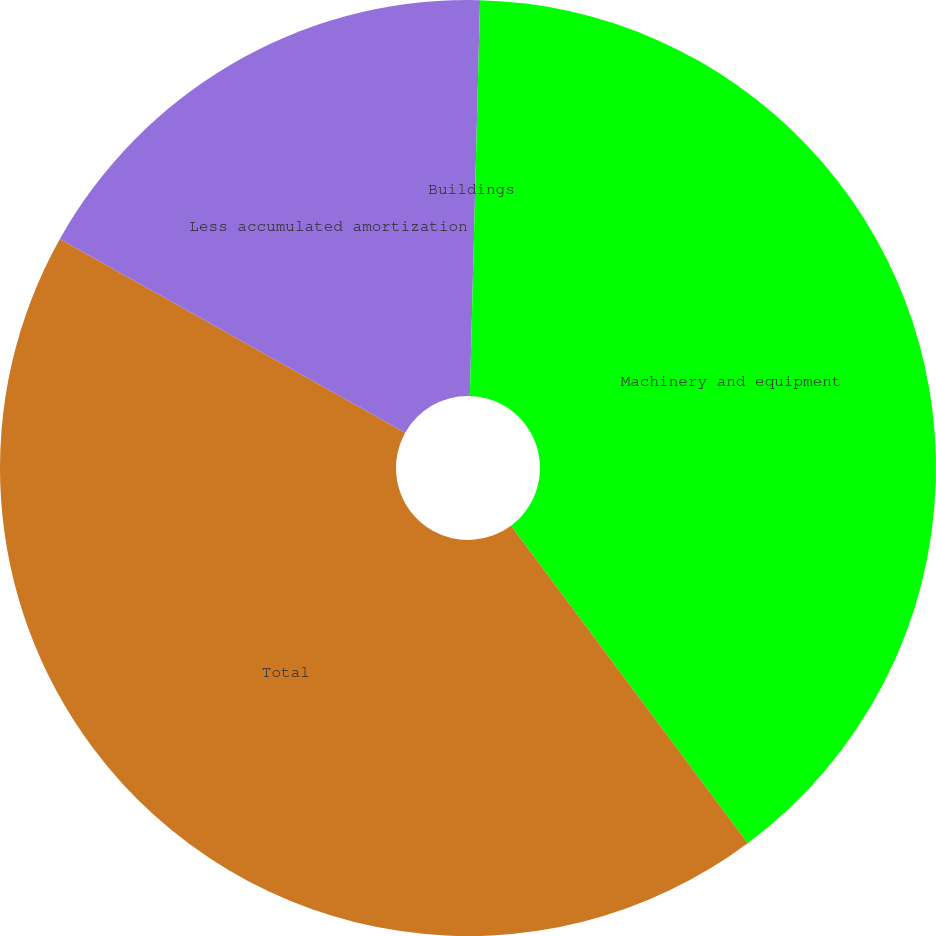Convert chart. <chart><loc_0><loc_0><loc_500><loc_500><pie_chart><fcel>Buildings<fcel>Machinery and equipment<fcel>Total<fcel>Less accumulated amortization<nl><fcel>0.41%<fcel>39.39%<fcel>43.33%<fcel>16.86%<nl></chart> 